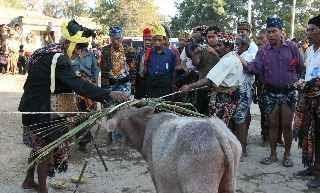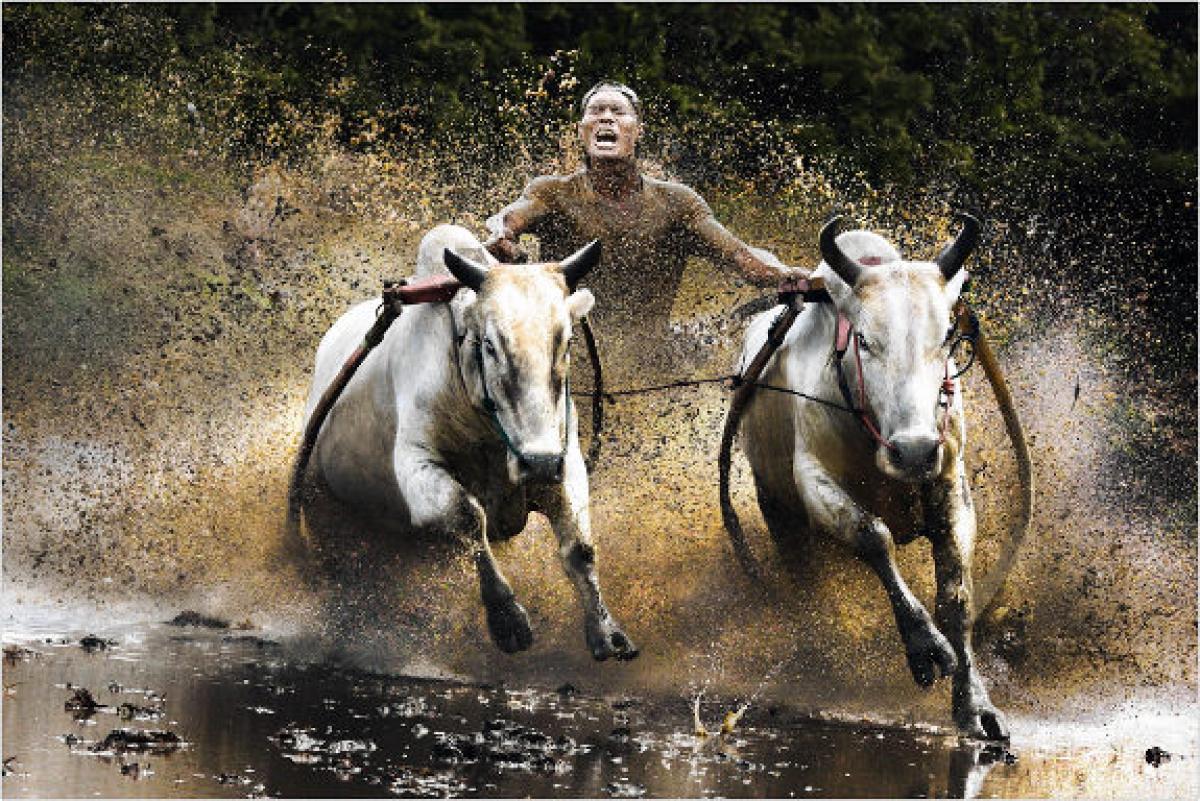The first image is the image on the left, the second image is the image on the right. Assess this claim about the two images: "A man is holding a whip.". Correct or not? Answer yes or no. No. The first image is the image on the left, the second image is the image on the right. Assess this claim about the two images: "One image is of one man with two beast of burden and the other image has one beast with multiple men.". Correct or not? Answer yes or no. Yes. 